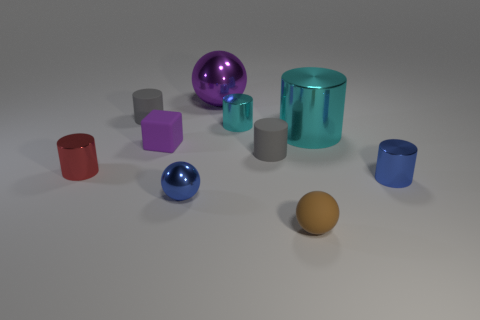Subtract all red cylinders. How many cylinders are left? 5 Subtract all big metallic cylinders. How many cylinders are left? 5 Subtract all purple cylinders. Subtract all gray blocks. How many cylinders are left? 6 Subtract all blocks. How many objects are left? 9 Subtract 0 gray balls. How many objects are left? 10 Subtract all small cyan shiny cylinders. Subtract all gray matte objects. How many objects are left? 7 Add 6 metal cylinders. How many metal cylinders are left? 10 Add 5 small cyan objects. How many small cyan objects exist? 6 